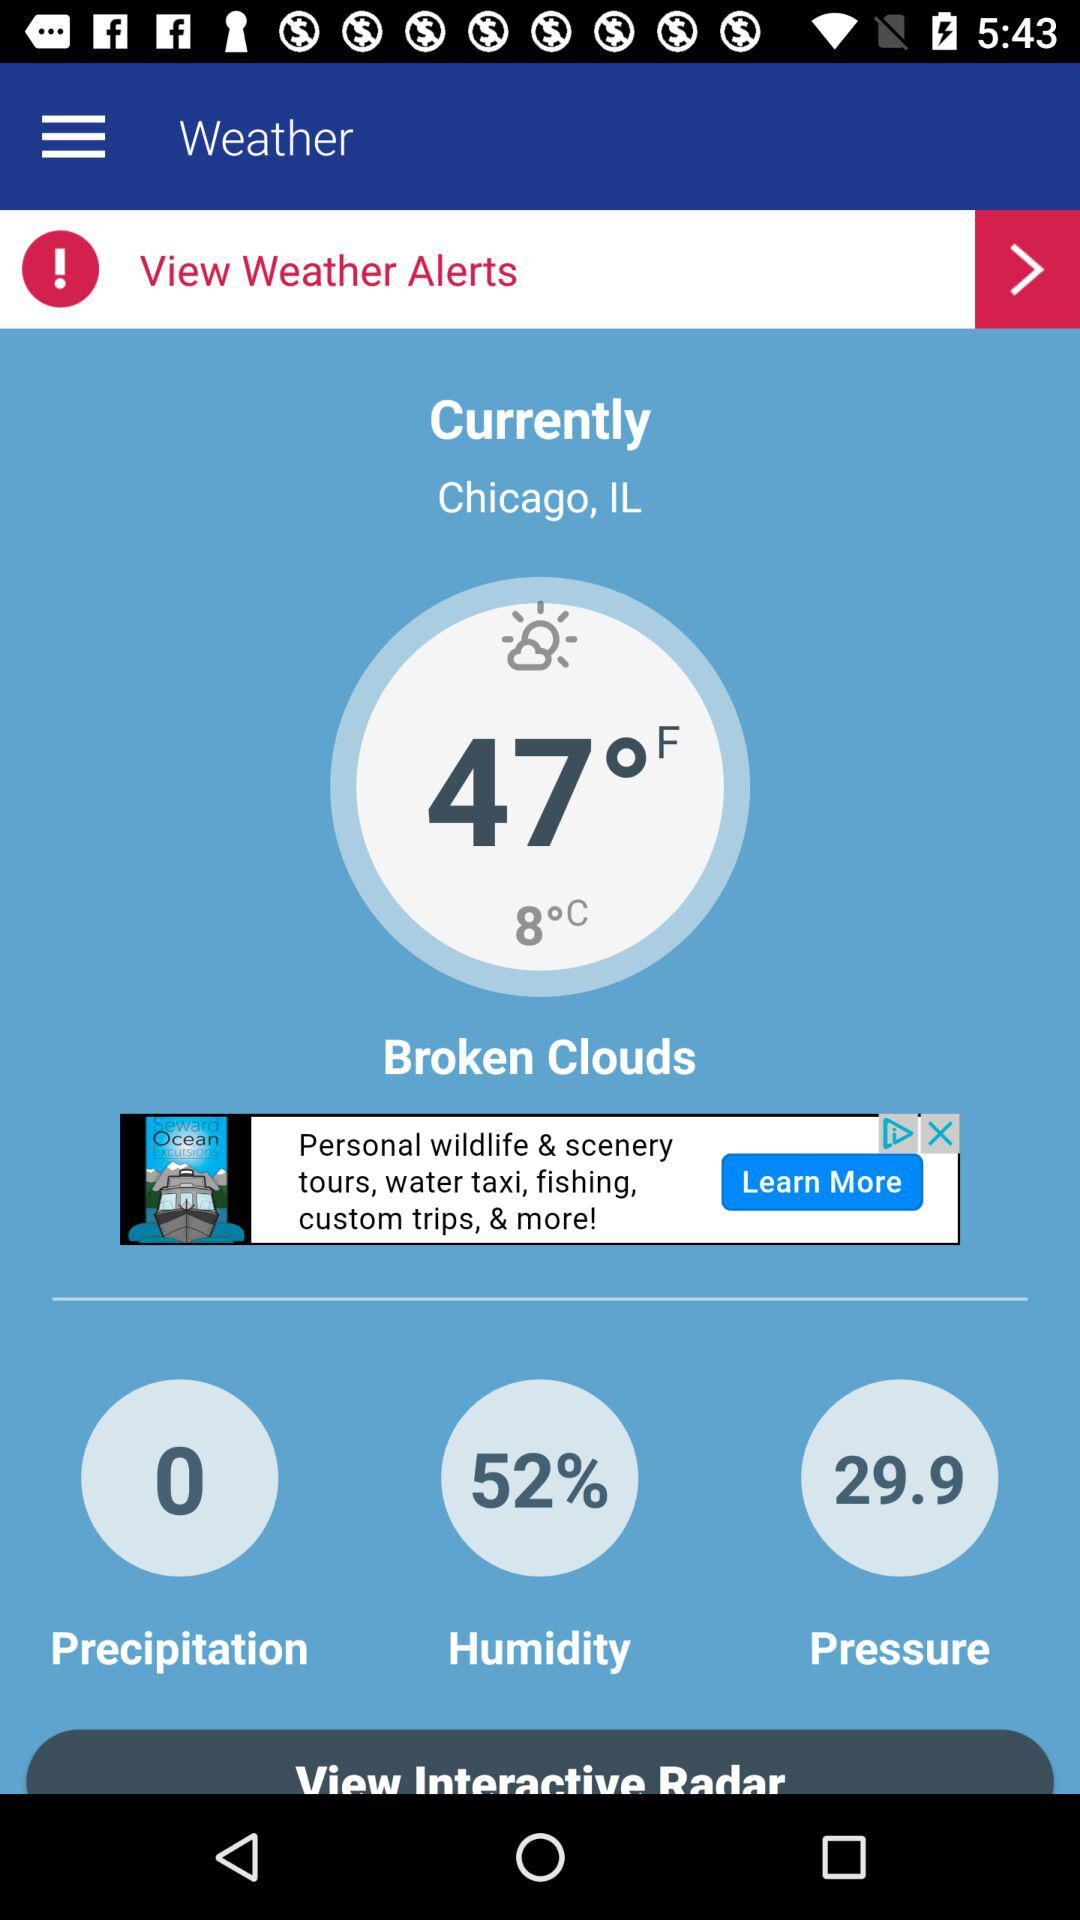How many degrees Fahrenheit is the temperature?
Answer the question using a single word or phrase. 47°F 